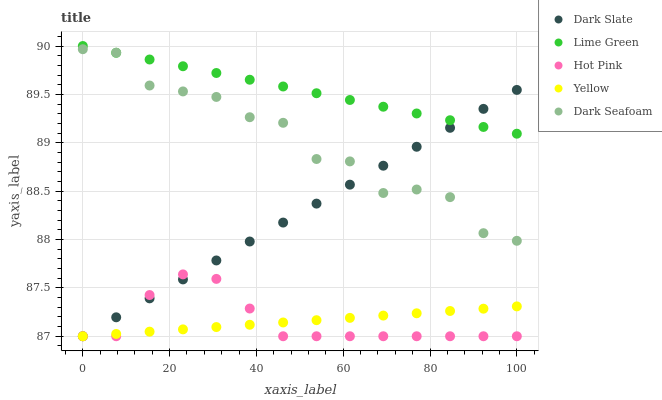Does Hot Pink have the minimum area under the curve?
Answer yes or no. Yes. Does Lime Green have the maximum area under the curve?
Answer yes or no. Yes. Does Dark Seafoam have the minimum area under the curve?
Answer yes or no. No. Does Dark Seafoam have the maximum area under the curve?
Answer yes or no. No. Is Yellow the smoothest?
Answer yes or no. Yes. Is Dark Seafoam the roughest?
Answer yes or no. Yes. Is Hot Pink the smoothest?
Answer yes or no. No. Is Hot Pink the roughest?
Answer yes or no. No. Does Dark Slate have the lowest value?
Answer yes or no. Yes. Does Dark Seafoam have the lowest value?
Answer yes or no. No. Does Lime Green have the highest value?
Answer yes or no. Yes. Does Dark Seafoam have the highest value?
Answer yes or no. No. Is Hot Pink less than Lime Green?
Answer yes or no. Yes. Is Dark Seafoam greater than Hot Pink?
Answer yes or no. Yes. Does Yellow intersect Dark Slate?
Answer yes or no. Yes. Is Yellow less than Dark Slate?
Answer yes or no. No. Is Yellow greater than Dark Slate?
Answer yes or no. No. Does Hot Pink intersect Lime Green?
Answer yes or no. No. 